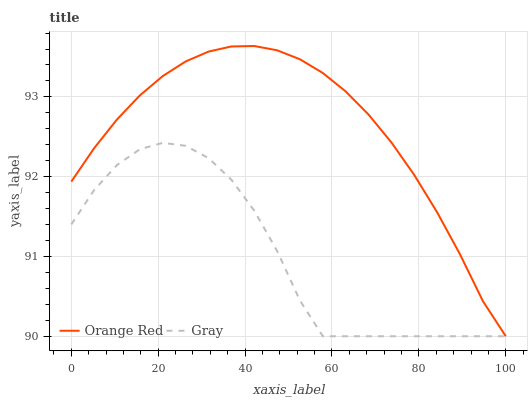Does Orange Red have the minimum area under the curve?
Answer yes or no. No. Is Orange Red the roughest?
Answer yes or no. No. 